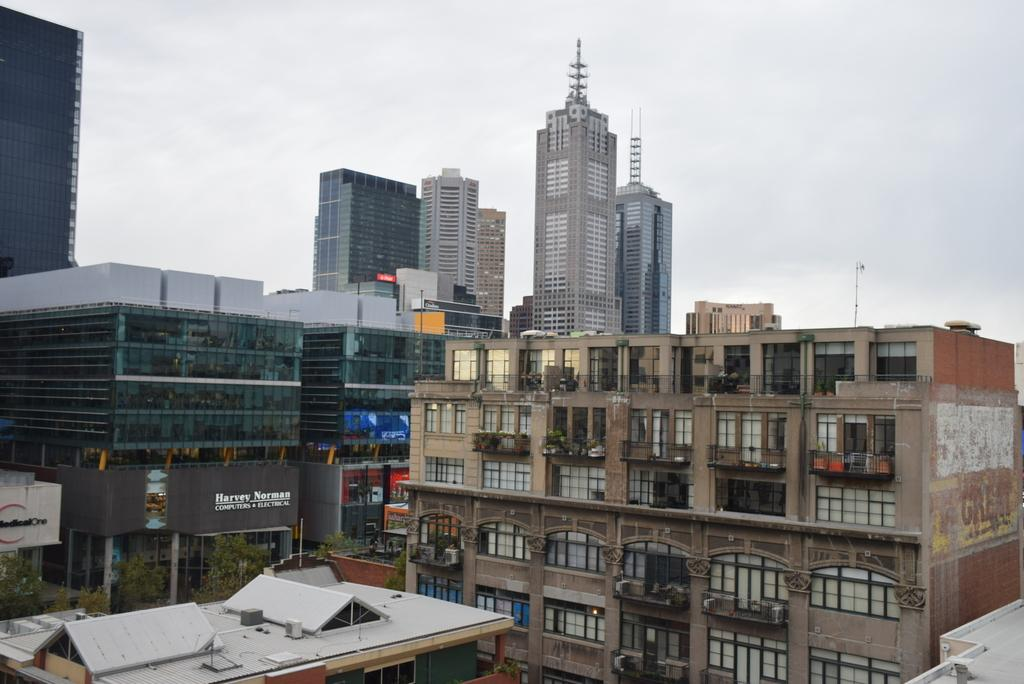What type of structures can be seen in the image? There are buildings in the image. What other natural elements are present in the image? There are trees in the image. Are there any words or symbols on the buildings? Yes, there is text on the walls of the buildings. How would you describe the weather in the image? The sky is cloudy in the image. Can you tell me how many sisters are playing baseball in the image? There are no sisters or baseball game present in the image. 